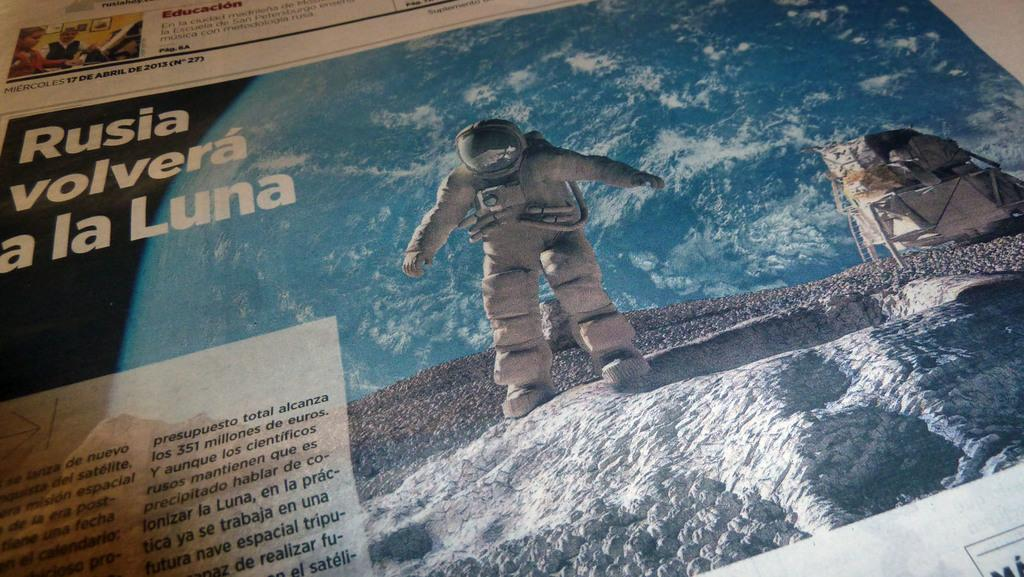What types of living organisms can be seen in the image? The image contains people. Is there any specific person or profession represented in the image? Yes, there is an astronaut in the image. What else can be found in the image besides people? There is information present in the image. Can you describe the object on the right side of the image? Unfortunately, the facts provided do not give enough information to describe the object on the right side of the image. How many beans are visible on the table in the image? There is no table or beans present in the image. What type of sheep can be seen in the image? There are no sheep present in the image. 